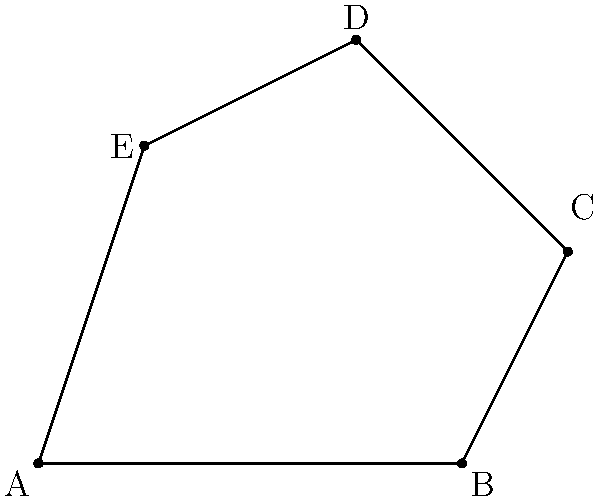In your work on documenting hand shapes for a minor sign language, you've represented a unique hand position as an irregular pentagon. The coordinates of the vertices are A(0,0), B(4,0), C(5,2), D(3,4), and E(1,3). Calculate the area of this pentagon to help quantify the hand shape for your digital resource. To calculate the area of this irregular pentagon, we'll use the shoelace formula (also known as the surveyor's formula). The steps are as follows:

1) First, let's arrange the coordinates in order:
   (x₁, y₁) = (0, 0)
   (x₂, y₂) = (4, 0)
   (x₃, y₃) = (5, 2)
   (x₄, y₄) = (3, 4)
   (x₅, y₅) = (1, 3)

2) The shoelace formula for a pentagon is:

   $$Area = \frac{1}{2}|(x₁y₂ + x₂y₃ + x₃y₄ + x₄y₅ + x₅y₁) - (y₁x₂ + y₂x₃ + y₃x₄ + y₄x₅ + y₅x₁)|$$

3) Let's substitute the values:

   $$Area = \frac{1}{2}|((0 \cdot 0) + (4 \cdot 2) + (5 \cdot 4) + (3 \cdot 3) + (1 \cdot 0)) - ((0 \cdot 4) + (0 \cdot 5) + (2 \cdot 3) + (4 \cdot 1) + (3 \cdot 0))|$$

4) Simplify:

   $$Area = \frac{1}{2}|(0 + 8 + 20 + 9 + 0) - (0 + 0 + 6 + 4 + 0)|$$
   $$Area = \frac{1}{2}|37 - 10|$$
   $$Area = \frac{1}{2}|27|$$
   $$Area = \frac{27}{2}$$
   $$Area = 13.5$$

5) Therefore, the area of the pentagon is 13.5 square units.
Answer: 13.5 square units 